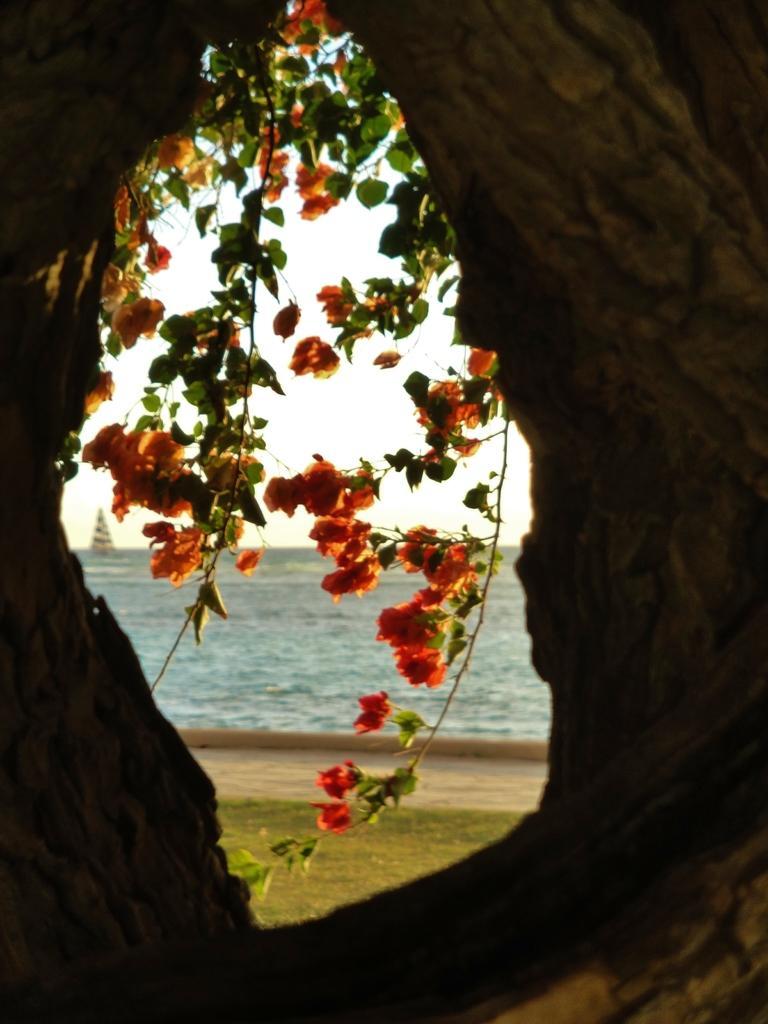In one or two sentences, can you explain what this image depicts? There's a hole. Through the hole we can see stems with leaves and flowers. In the back there is water and sky. On the water there is a boat. 